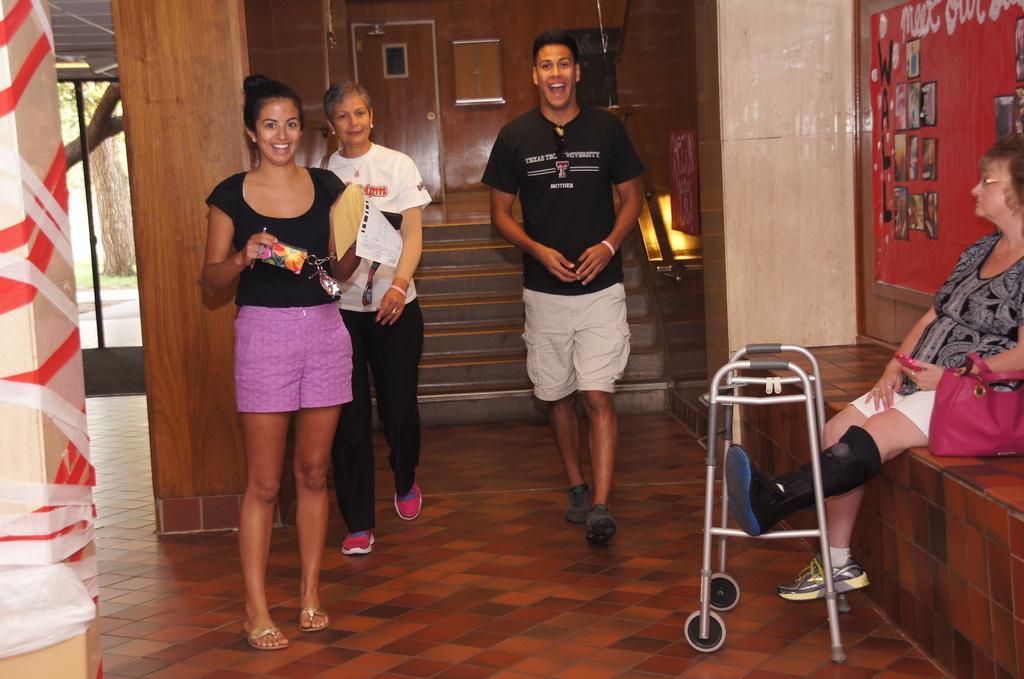Describe this image in one or two sentences. In this image I can see four people with different color dresses. I can see three people are standing and one person is sitting. To the right I can see the handicapped equipment, bag and many frames to the wall. In the background I can see the wooden wall and the glass door. Through the glass I can see the tree. 